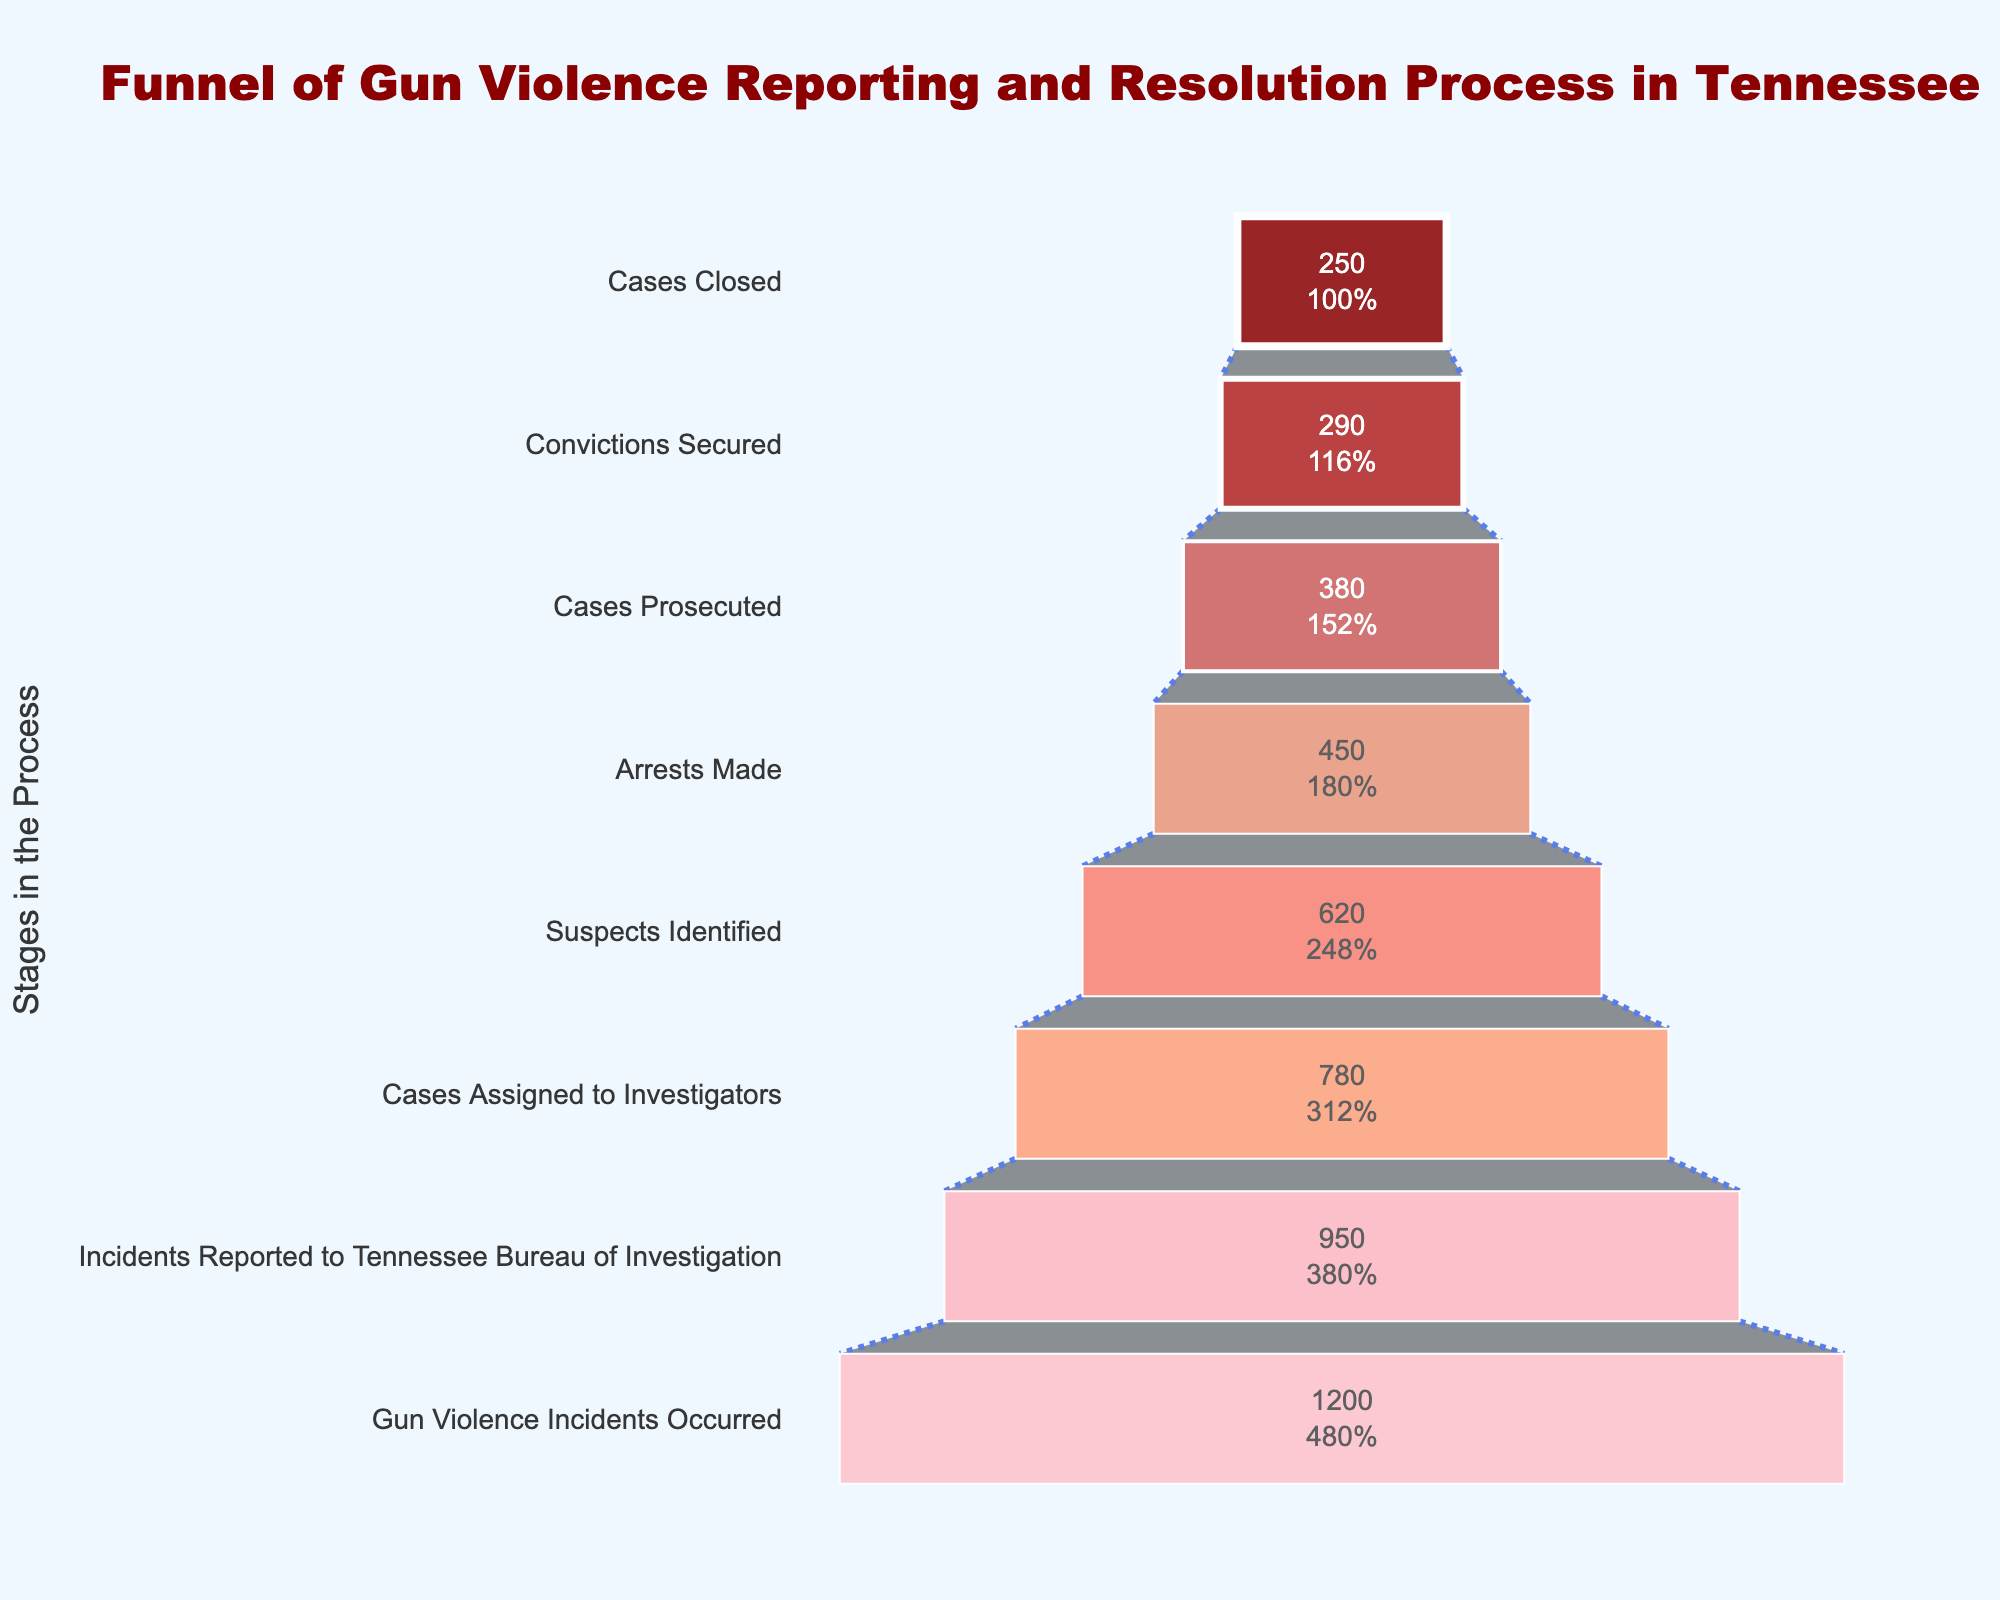What's the title of the figure? The title of the figure is prominently displayed at the top and reads "Funnel of Gun Violence Reporting and Resolution Process in Tennessee."
Answer: Funnel of Gun Violence Reporting and Resolution Process in Tennessee How many cases were reported to the Tennessee Bureau of Investigation? This information is visible in the second stage of the funnel chart. The number of cases reported to the Tennessee Bureau of Investigation is shown directly.
Answer: 950 What is the smallest number of cases at any stage? The funnel chart shows the number of cases at each stage; the smallest number is at the last stage, "Cases Closed."
Answer: 250 Which stage sees the greatest drop in the number of cases compared to the previous stage? By comparing each stage's number of cases to its preceding stage, the largest drop is seen between "Gun Violence Incidents Occurred" and "Incidents Reported to Tennessee Bureau of Investigation."
Answer: Gun Violence Incidents Occurred to Incidents Reported Are there more cases where arrests were made or where cases were prosecuted? The funnel chart shows the number of cases for both stages; compare them directly. There are more cases where arrests were made (450) than cases prosecuted (380).
Answer: Arrests Made How is the color pattern of the bars in the funnel chart? The bars in the funnel chart go from darker to lighter shades of red as you move from top to bottom.
Answer: Darker to lighter shades of red What is the stage directly after "Cases Prosecuted"? According to the funnel chart, the stage following "Cases Prosecuted" is "Convictions Secured."
Answer: Convictions Secured 